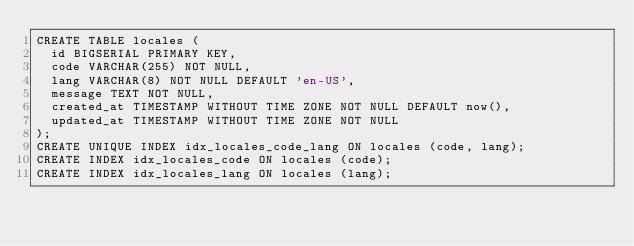<code> <loc_0><loc_0><loc_500><loc_500><_SQL_>CREATE TABLE locales (
  id BIGSERIAL PRIMARY KEY,
  code VARCHAR(255) NOT NULL,
  lang VARCHAR(8) NOT NULL DEFAULT 'en-US',
  message TEXT NOT NULL,
  created_at TIMESTAMP WITHOUT TIME ZONE NOT NULL DEFAULT now(),
  updated_at TIMESTAMP WITHOUT TIME ZONE NOT NULL
);
CREATE UNIQUE INDEX idx_locales_code_lang ON locales (code, lang);
CREATE INDEX idx_locales_code ON locales (code);
CREATE INDEX idx_locales_lang ON locales (lang);
</code> 